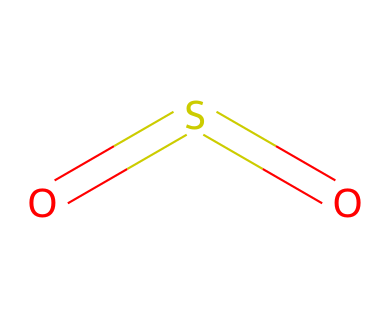what is the name of this chemical structure? The SMILES representation "O=S=O" describes sulfur dioxide. The representation indicates that the compound consists of one sulfur atom bonded to two oxygen atoms with double bonds.
Answer: sulfur dioxide how many sulfur atoms are present? In the given SMILES "O=S=O," there is one sulfur atom represented by the 'S.'
Answer: one what is the oxidation state of sulfur in this compound? The oxidation state of sulfur in sulfur dioxide is +4. This is determined by considering that each oxygen typically has an oxidation state of -2 and the overall charge of the molecule is neutral, leading to the equation: S + 2(-2) = 0; thus S = +4.
Answer: +4 how many total bonds are formed in sulfur dioxide? The SMILES depicts that sulfur is forming two double bonds with oxygen atoms. Each double bond counts as two bonds, making a total of four bonds.
Answer: four what type of bonding is present in this sulfur compound? The compound exhibits covalent bonding, evidenced by the sharing of electrons between sulfur and oxygen in the double bonds. Covalent bonds are characterized by the sharing of valence electrons.
Answer: covalent what is a common use of sulfur dioxide in preservation? Sulfur dioxide is commonly used as a preservative to prevent spoilage and discoloration in a variety of food products and even in theatrical set pieces. Its properties help in preserving the integrity of materials over time.
Answer: preservation 